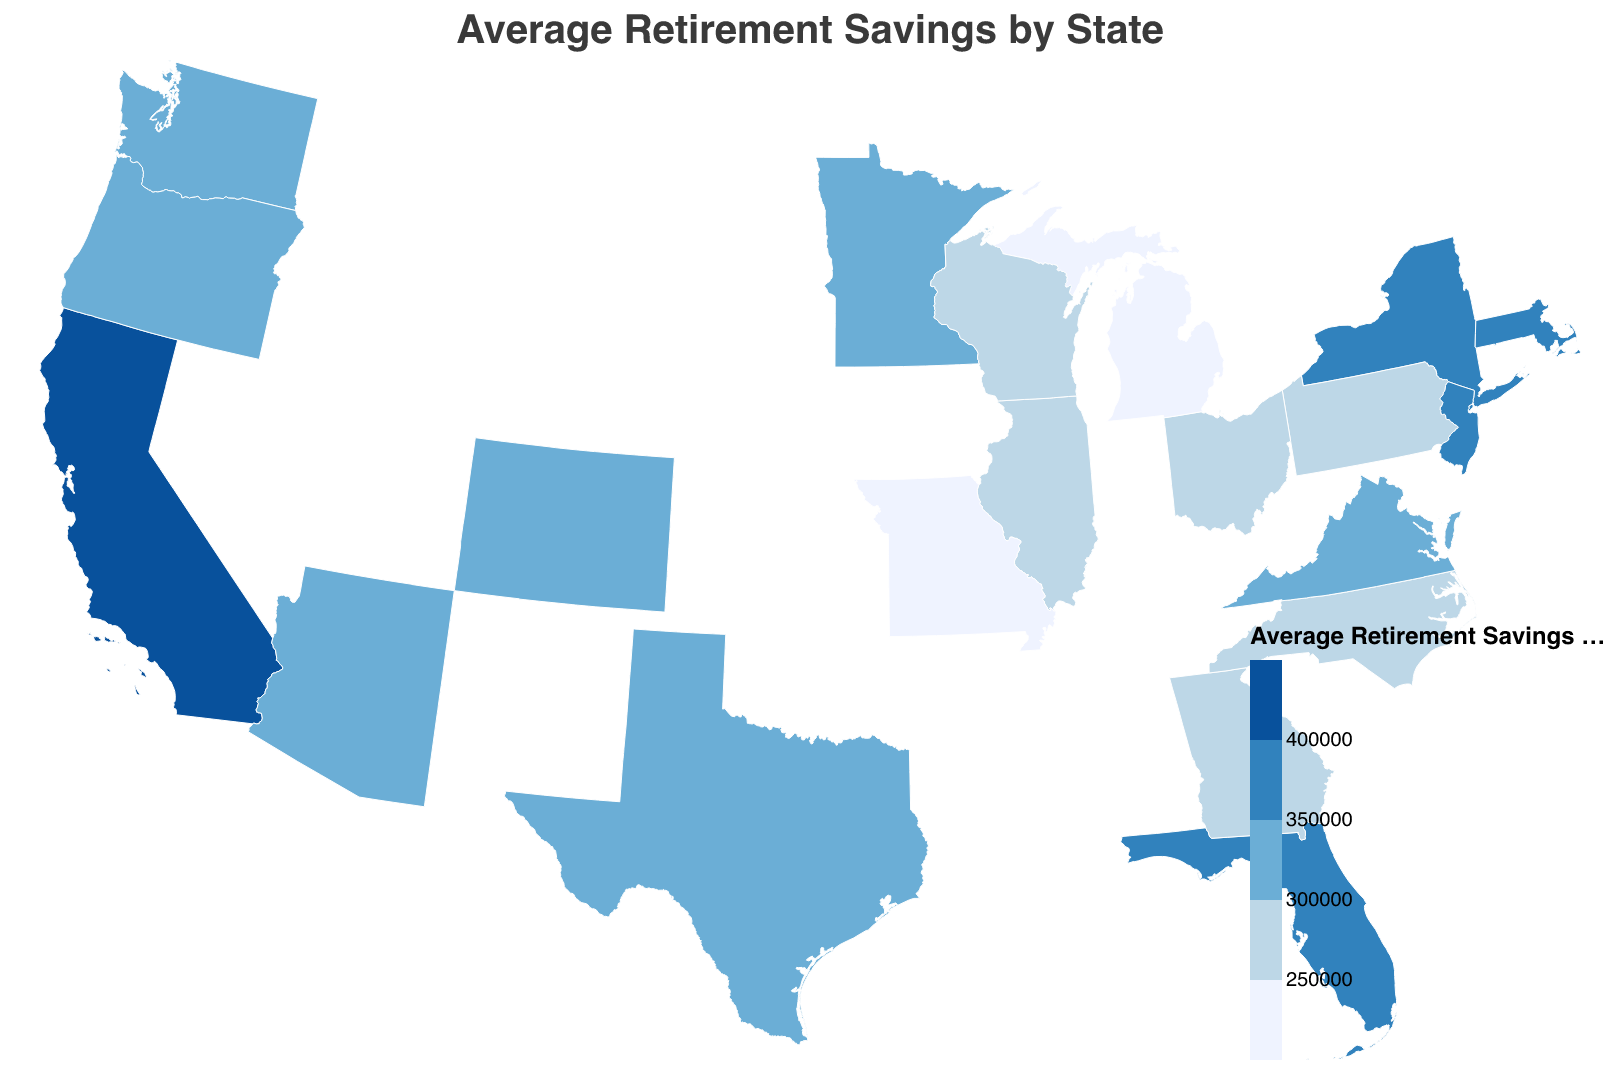What is the title of the plot? The title of the plot is prominently displayed at the top of the figure. The title text is "Average Retirement Savings by State."
Answer: Average Retirement Savings by State Which state has the highest average retirement savings? By examining the color gradient, we see that California is marked with the darkest shade indicating the highest value. The tooltip confirms that California has the highest average retirement savings of $412,000.
Answer: California How do the average retirement savings in New York and Texas compare? By looking at their respective colors and tooltips, New York’s savings are $380,000, while Texas’s savings are $325,000. Since $380,000 is greater than $325,000, New York has higher average retirement savings.
Answer: New York has higher retirement savings than Texas What is the average retirement savings of states that fall into the color range representing savings between $250,000 and $300,000? The states within this range are Illinois ($290,000), Pennsylvania ($275,000), Ohio ($260,000), Georgia ($280,000), North Carolina ($270,000), Wisconsin ($255,000), Missouri ($240,000). Calculating the average: 
(290000 + 275000 + 260000 + 280000 + 270000 + 255000 + 240000) / 7 = 269285.
Answer: $269,285 Which states have average retirement savings greater than $350,000? By identifying the states with shading corresponding to $350,000 and above, we find California ($412,000), New York ($380,000), Massachusetts ($395,000), New Jersey ($365,000), and Washington ($335,000). Reviewing the exact values, the states are: California, New York, Massachusetts, and New Jersey.
Answer: California, New York, Massachusetts, New Jersey What color represents an average retirement savings of around $310,000, and which state falls into this category? By referencing the color scale, the shade representing around $310,000 is in the third range (light blue). The states in this bracket are Virginia ($310,000), and Colorado ($320,000). Given that $310,000 matches directly with Virginia:
Answer: Light blue, Virginia What pattern do you see in terms of regional retirement savings in the northern vs. southern states? Observing the geographic layout, northern states such as Massachusetts, New York, and New Jersey tend to have higher average retirement savings (darker shades). Southern states like Georgia, North Carolina, and Florida show moderately lower retirement savings (lighter shades). This implies a general trend where northern states have relatively higher savings compared to southern states.
Answer: Northern states generally have higher retirement savings Explain the distribution of retirement savings in the states on the west coast. On the west coast, California has the highest retirement savings at $412,000. Washington follows with $335,000, and Oregon has $300,000. This indicates a relatively high average retirement savings in this region.
Answer: High with California being the highest Between Colorado and Georgia, which state has higher average retirement savings and by how much? Colorado has an average retirement savings of $320,000, while Georgia stands at $280,000. The difference is $320,000 - $280,000 = $40,000.
Answer: Colorado by $40,000 What is the visual gradient used to represent different levels of retirement savings on this map, and how does it help in understanding the data? The visual gradient progresses from light blue to dark blue as the average retirement savings increase. Light blue represents lower savings, while dark blue represents higher savings. This gradient helps in quickly visualizing and comparing regional differences in retirement savings across states.
Answer: Light to dark blue gradient helps in quick comparison 